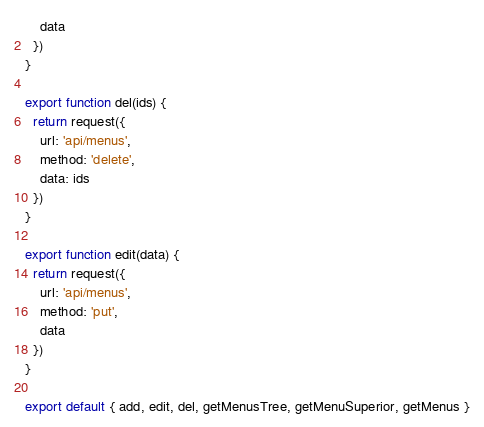Convert code to text. <code><loc_0><loc_0><loc_500><loc_500><_JavaScript_>    data
  })
}

export function del(ids) {
  return request({
    url: 'api/menus',
    method: 'delete',
    data: ids
  })
}

export function edit(data) {
  return request({
    url: 'api/menus',
    method: 'put',
    data
  })
}

export default { add, edit, del, getMenusTree, getMenuSuperior, getMenus }
</code> 